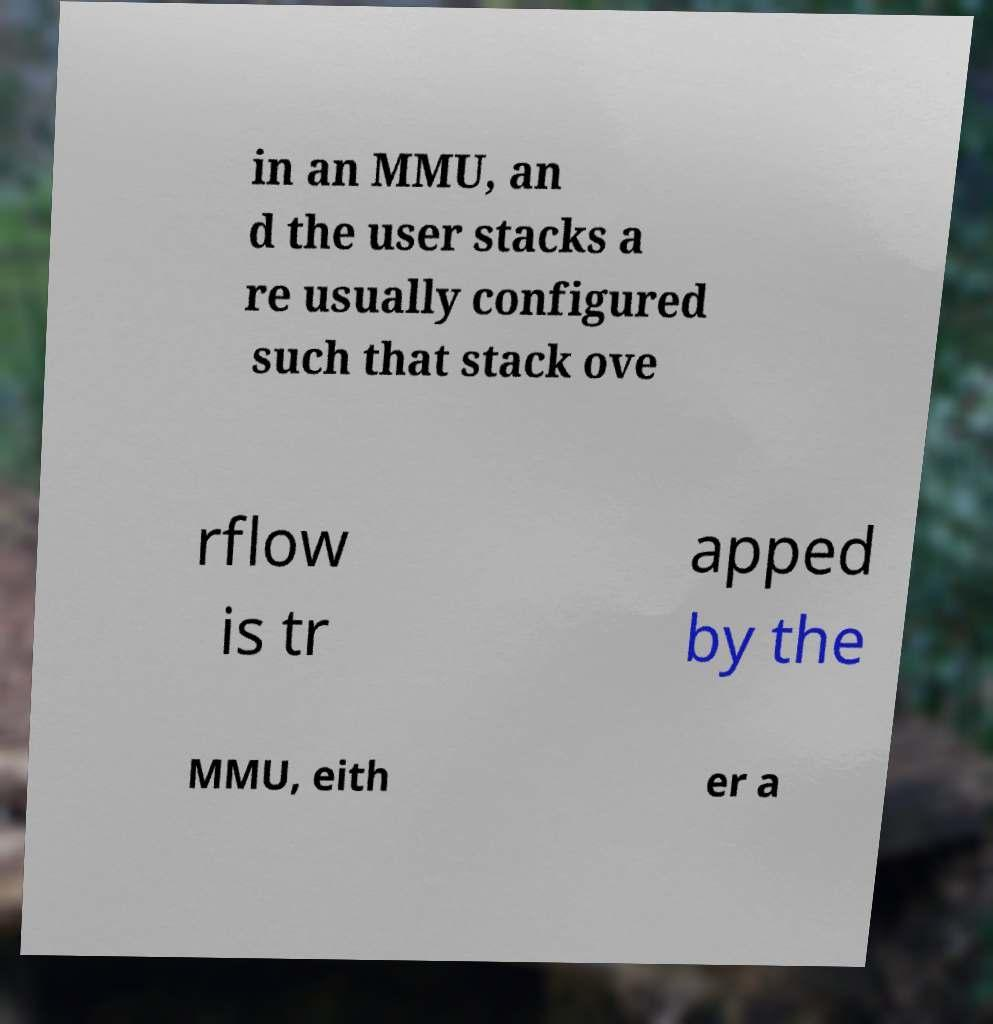I need the written content from this picture converted into text. Can you do that? in an MMU, an d the user stacks a re usually configured such that stack ove rflow is tr apped by the MMU, eith er a 